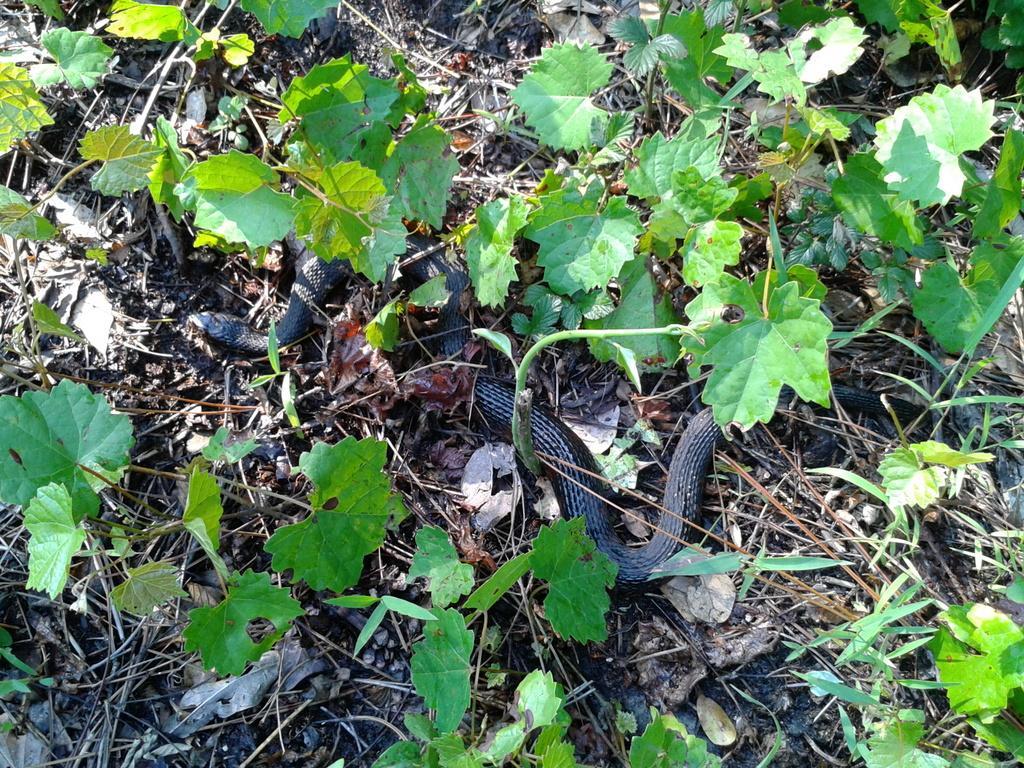Can you describe this image briefly? In this picture we can see a snake on the ground, here we can see leaves, some sticks. 